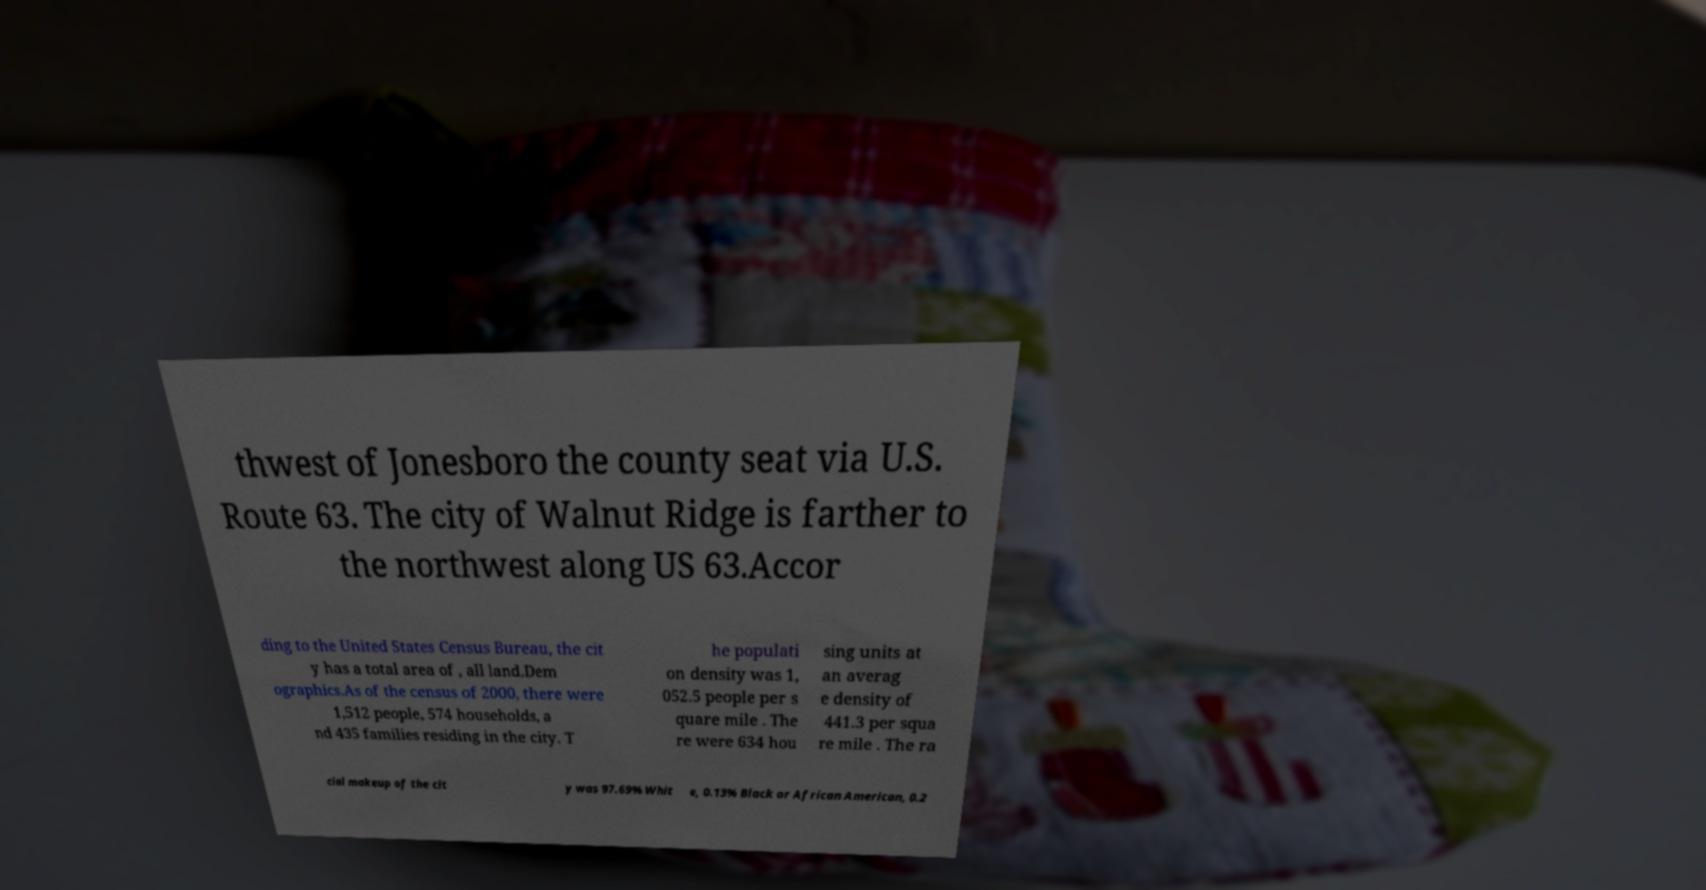Could you assist in decoding the text presented in this image and type it out clearly? thwest of Jonesboro the county seat via U.S. Route 63. The city of Walnut Ridge is farther to the northwest along US 63.Accor ding to the United States Census Bureau, the cit y has a total area of , all land.Dem ographics.As of the census of 2000, there were 1,512 people, 574 households, a nd 435 families residing in the city. T he populati on density was 1, 052.5 people per s quare mile . The re were 634 hou sing units at an averag e density of 441.3 per squa re mile . The ra cial makeup of the cit y was 97.69% Whit e, 0.13% Black or African American, 0.2 